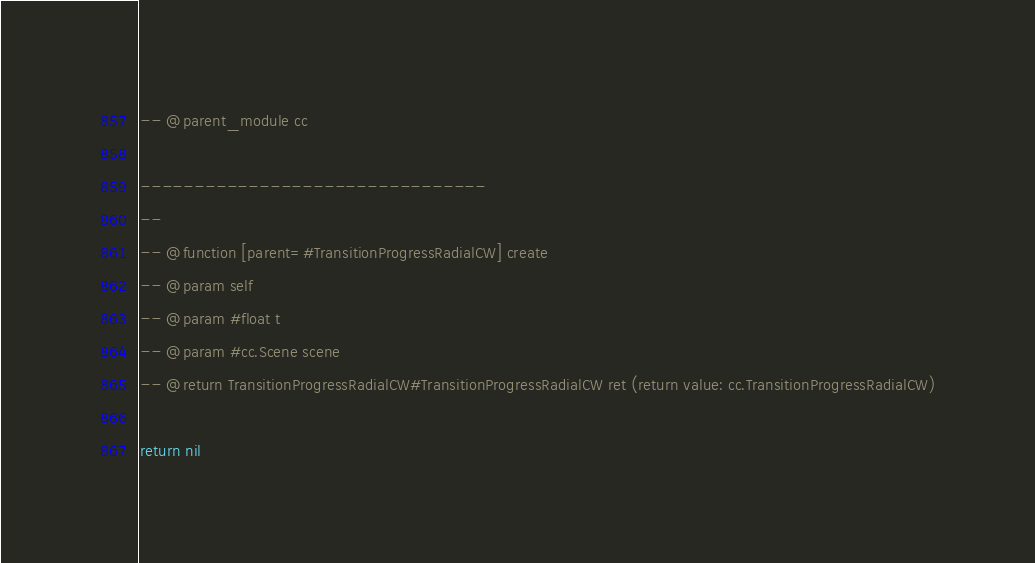Convert code to text. <code><loc_0><loc_0><loc_500><loc_500><_Lua_>-- @parent_module cc

--------------------------------
-- 
-- @function [parent=#TransitionProgressRadialCW] create 
-- @param self
-- @param #float t
-- @param #cc.Scene scene
-- @return TransitionProgressRadialCW#TransitionProgressRadialCW ret (return value: cc.TransitionProgressRadialCW)
        
return nil
</code> 